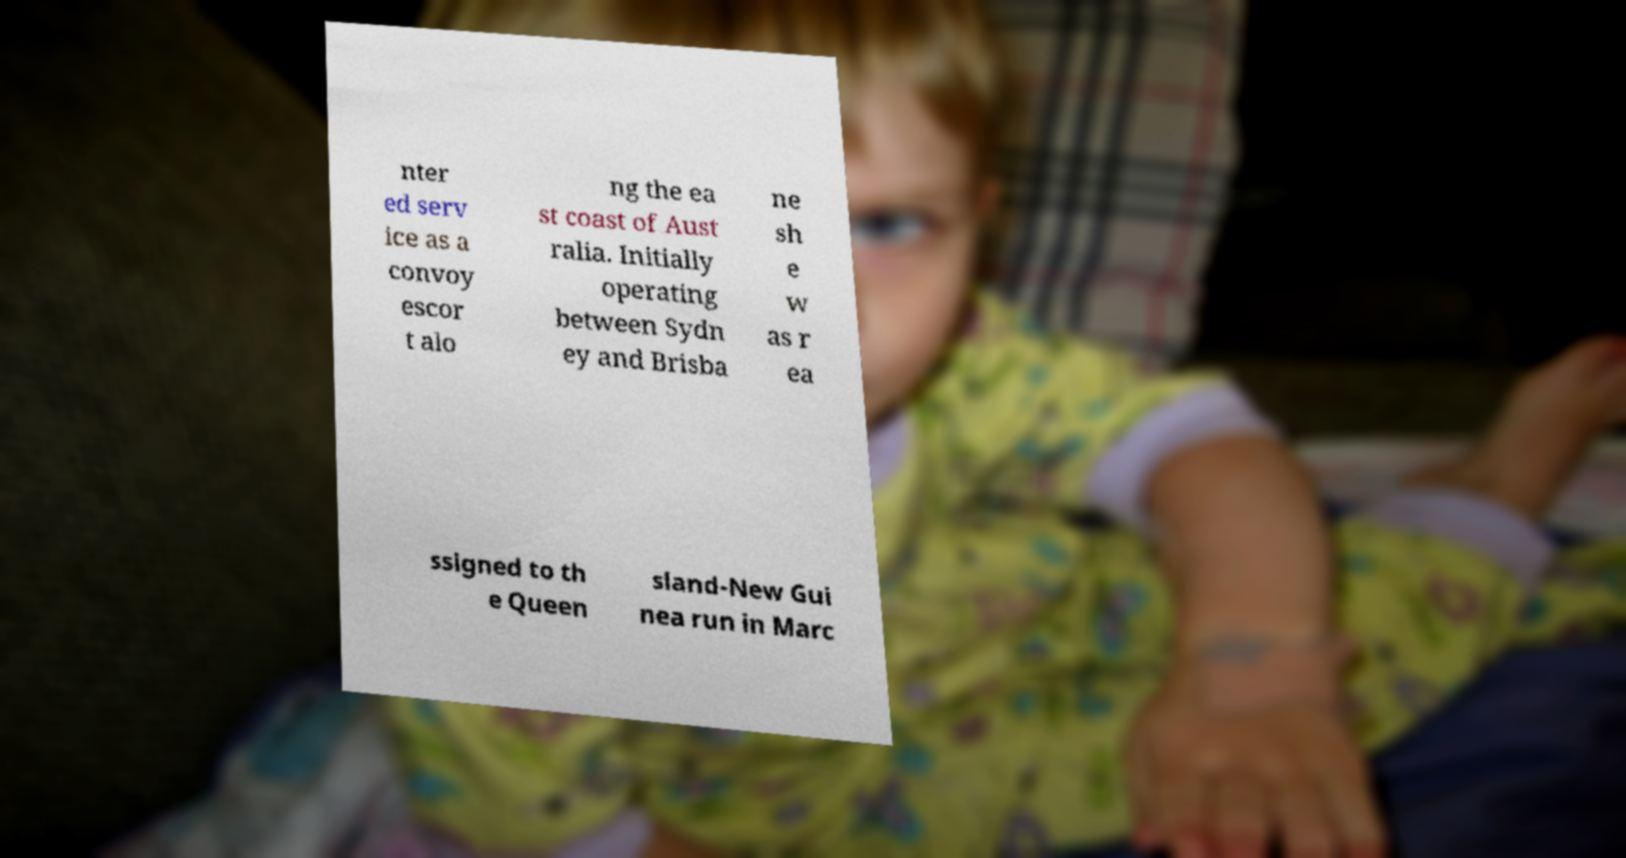Please read and relay the text visible in this image. What does it say? nter ed serv ice as a convoy escor t alo ng the ea st coast of Aust ralia. Initially operating between Sydn ey and Brisba ne sh e w as r ea ssigned to th e Queen sland-New Gui nea run in Marc 